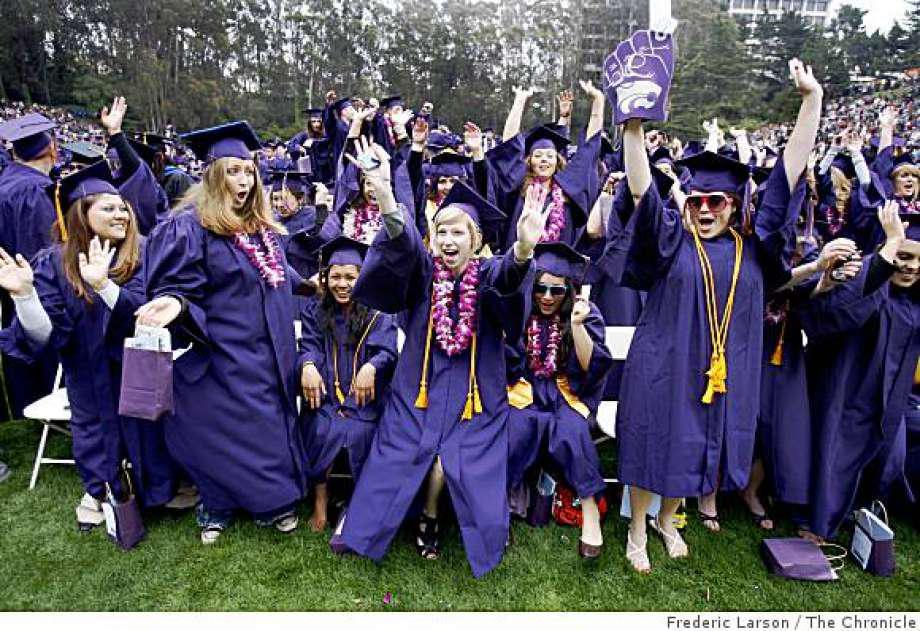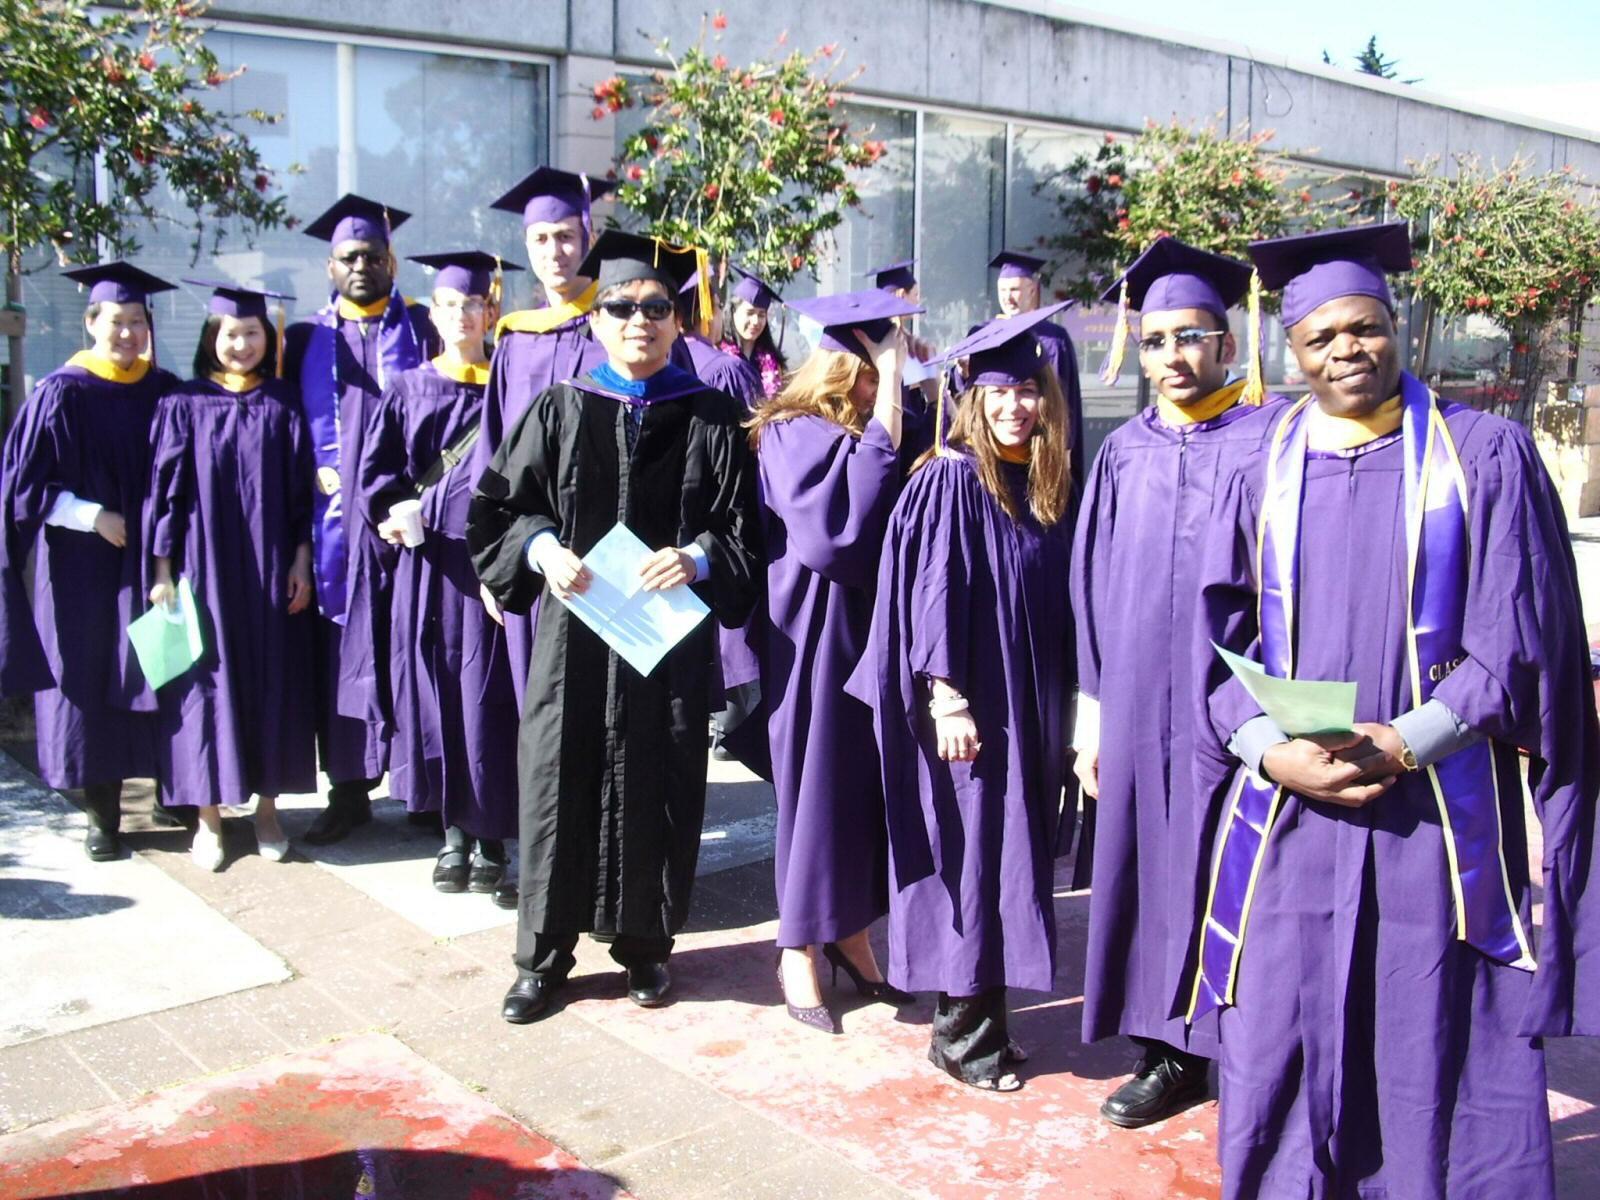The first image is the image on the left, the second image is the image on the right. Examine the images to the left and right. Is the description "One image features a single graduate in the foreground raising at least one hand in the air, and wearing a royal purple robe with yellow around the neck and a hat with a tassle." accurate? Answer yes or no. No. The first image is the image on the left, the second image is the image on the right. Given the left and right images, does the statement "No more than two people in graduation robes can be seen in either picture." hold true? Answer yes or no. No. 